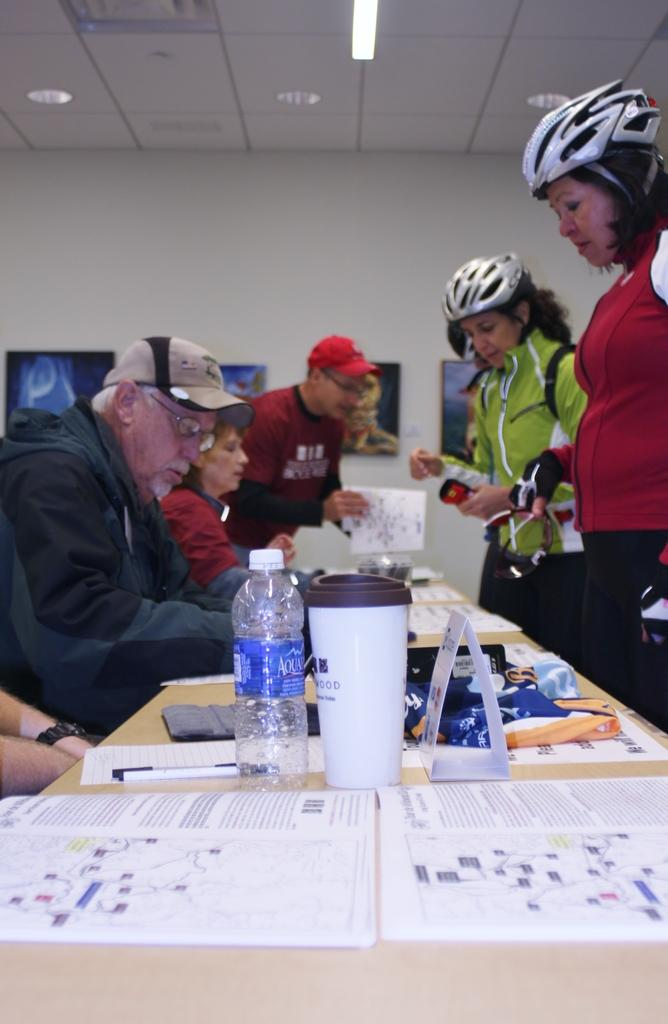What is on the table in the image? There are a few objects on the table in the image. What are the people in the image doing? The people in the image are sitting on chairs and standing behind the table. What can be seen on the wall behind the people? There are photo frames on the wall behind the people. How many roses are on the table in the image? There are no roses present on the table in the image. What type of houses can be seen in the background of the image? There are no houses visible in the image; it only shows a table with objects and people around it. 